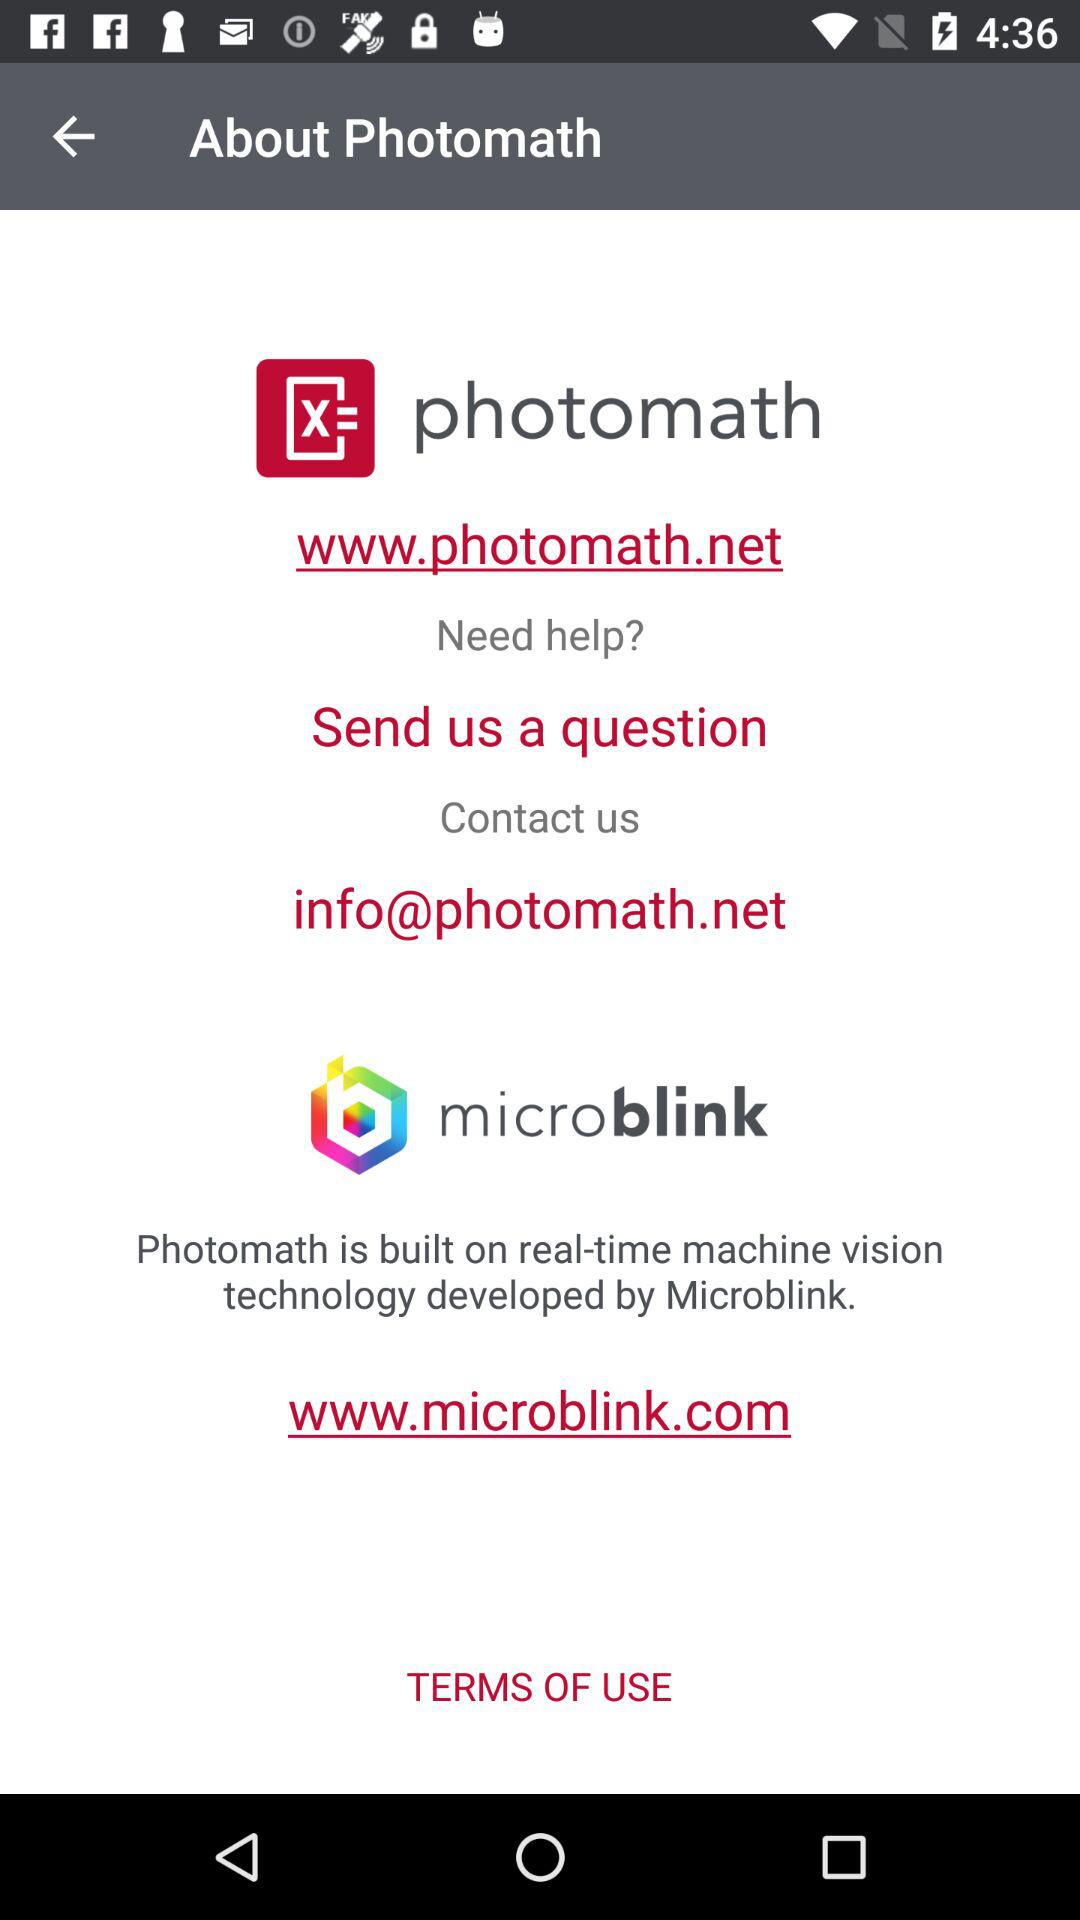What is the web address of "photomath"? The web address of "photomath" is www.photomath.net. 